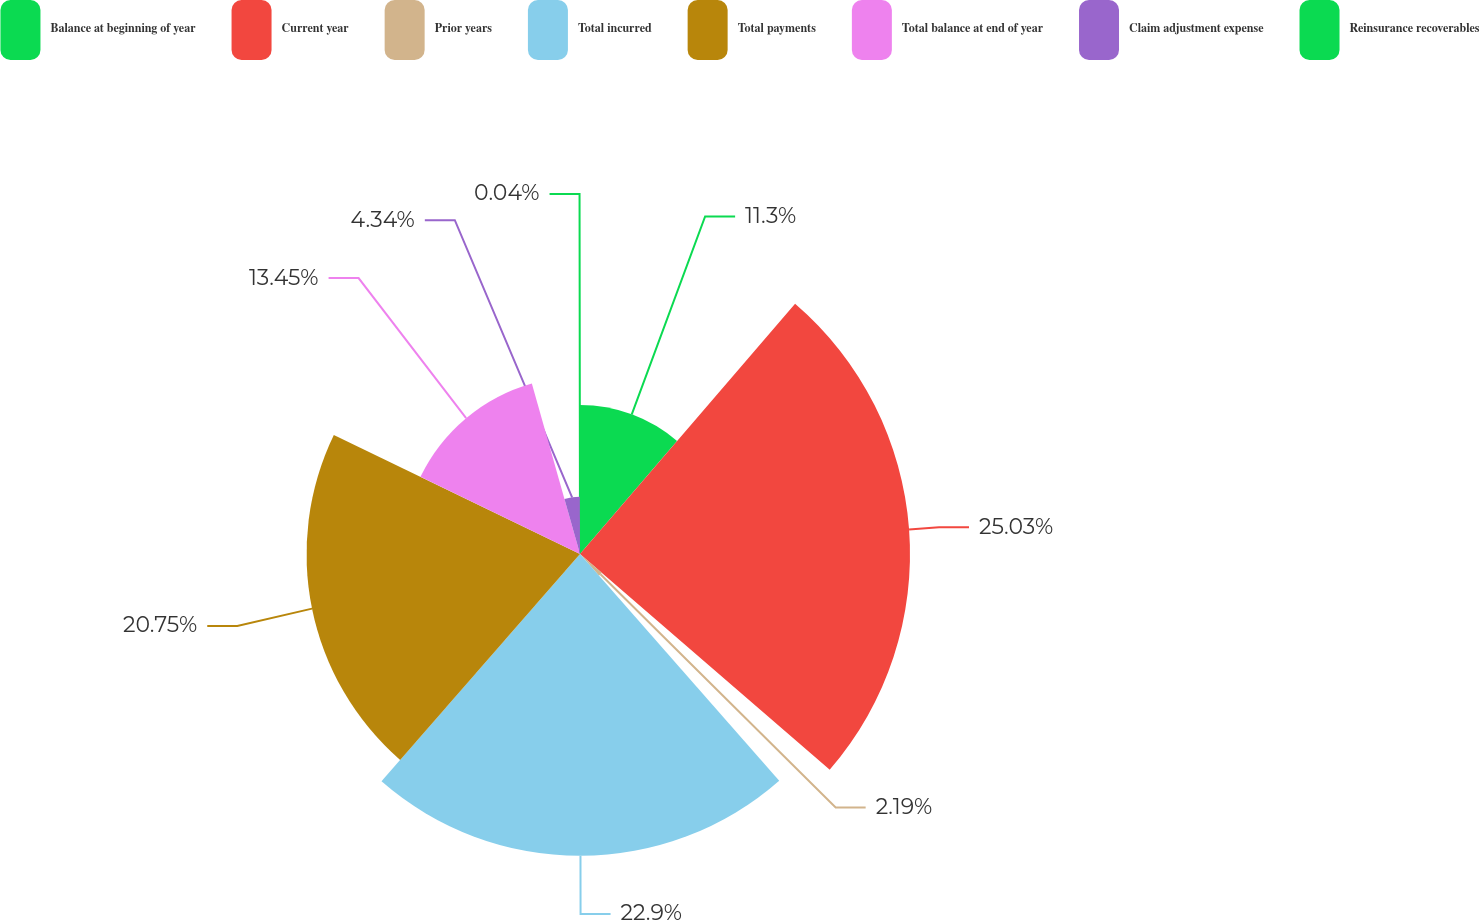Convert chart to OTSL. <chart><loc_0><loc_0><loc_500><loc_500><pie_chart><fcel>Balance at beginning of year<fcel>Current year<fcel>Prior years<fcel>Total incurred<fcel>Total payments<fcel>Total balance at end of year<fcel>Claim adjustment expense<fcel>Reinsurance recoverables<nl><fcel>11.3%<fcel>25.04%<fcel>2.19%<fcel>22.9%<fcel>20.75%<fcel>13.45%<fcel>4.34%<fcel>0.04%<nl></chart> 